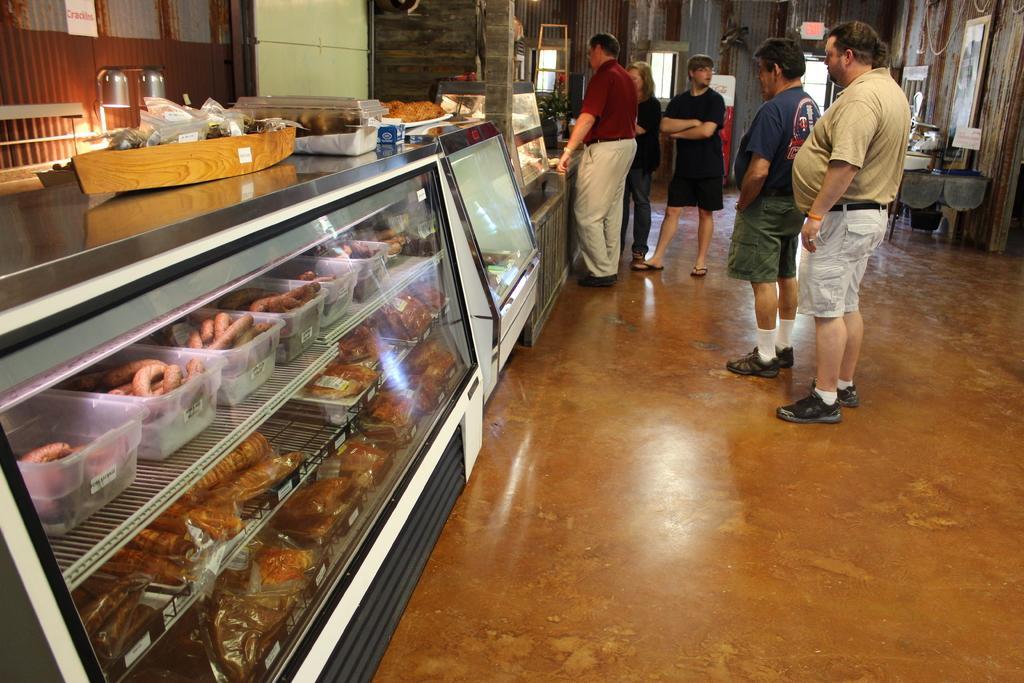Could you give a brief overview of what you see in this image? In this picture we can observe some people standing. On the right side there is a shelf in which there is some food places. In the background there is a wall and a windows. On the right side we can observe a photo frame fixed to the wall. 